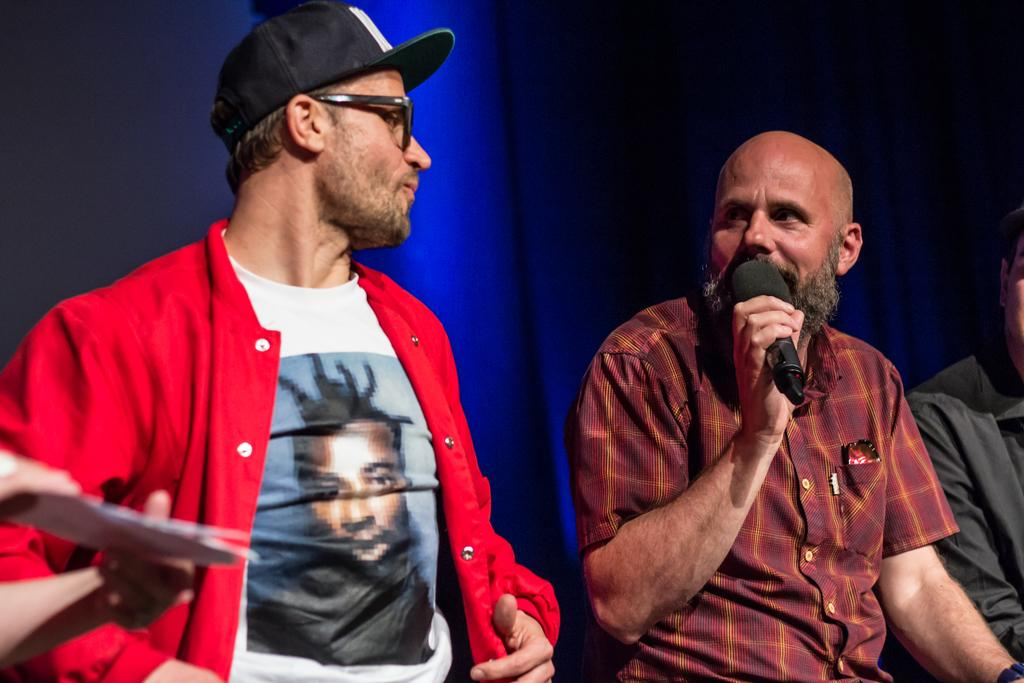How many persons are in the image? There are two persons in the image. What is one of the persons doing in the image? One of the persons is talking on a microphone. Can you describe the appearance of the person talking on the microphone? The person talking on the microphone is wearing spectacles and a cap. What type of seed is being exchanged between the two persons in the image? There is no seed present in the image, nor is there any indication of an exchange between the two persons. What type of truck can be seen in the background of the image? There is no truck visible in the image. 